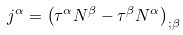<formula> <loc_0><loc_0><loc_500><loc_500>j ^ { \alpha } = \left ( \tau ^ { \alpha } N ^ { \beta } - \tau ^ { \beta } N ^ { \alpha } \right ) _ { ; \beta }</formula> 